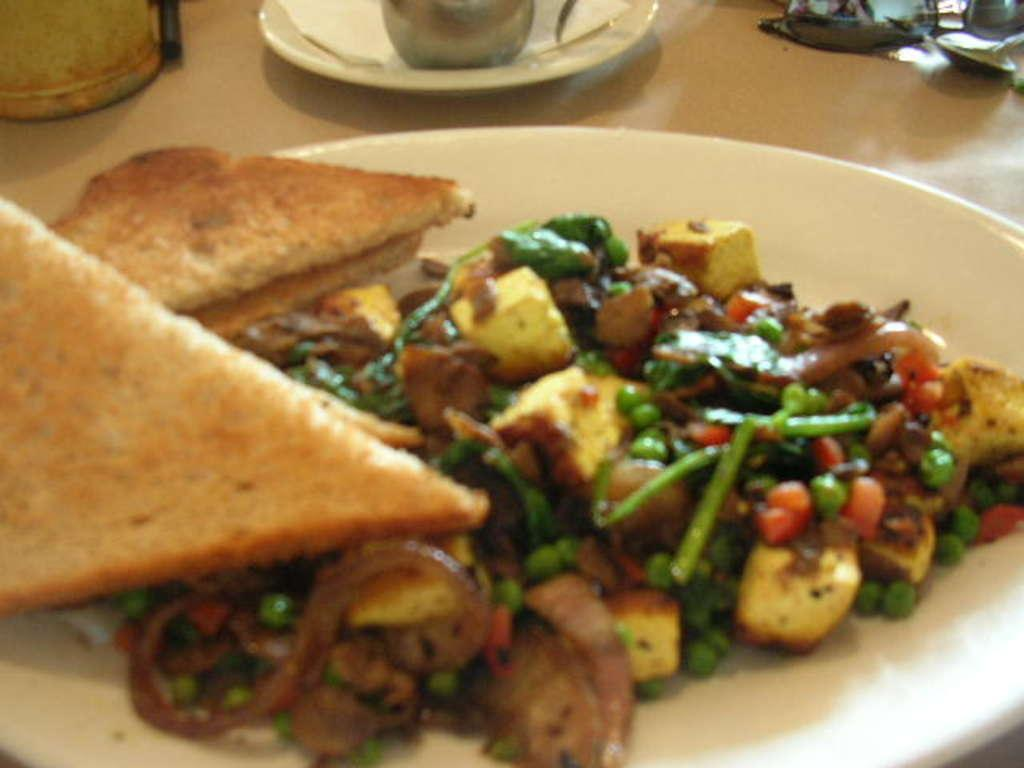What objects are present on the plates in the image? There is food in the image, which is likely on the plates. What type of material is used for cleaning or wiping in the image? Tissue paper is visible in the image, which can be used for cleaning or wiping. What is the nature of the objects on the platform in the image? There are objects on a platform in the image, but the specific nature of these objects is not mentioned in the facts. Can you see a robin flying down a slope in the image? No, there is no mention of a robin or a slope in the image. 